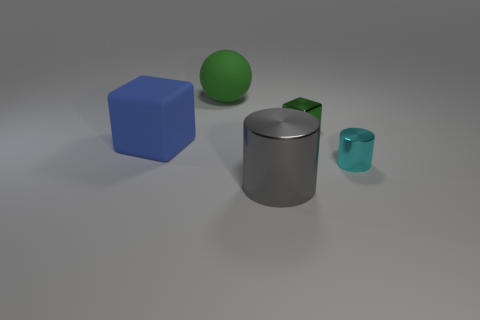Subtract all gray cylinders. How many cylinders are left? 1 Add 1 big blue spheres. How many objects exist? 6 Subtract all cylinders. How many objects are left? 3 Subtract all brown balls. Subtract all cyan cylinders. How many balls are left? 1 Subtract all red cubes. How many blue spheres are left? 0 Subtract all large cyan blocks. Subtract all small green things. How many objects are left? 4 Add 3 small metallic cylinders. How many small metallic cylinders are left? 4 Add 2 small cyan cylinders. How many small cyan cylinders exist? 3 Subtract 0 purple cylinders. How many objects are left? 5 Subtract 1 blocks. How many blocks are left? 1 